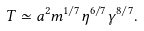Convert formula to latex. <formula><loc_0><loc_0><loc_500><loc_500>T \simeq a ^ { 2 } m ^ { 1 / 7 } \eta ^ { 6 / 7 } \gamma ^ { 8 / 7 } .</formula> 